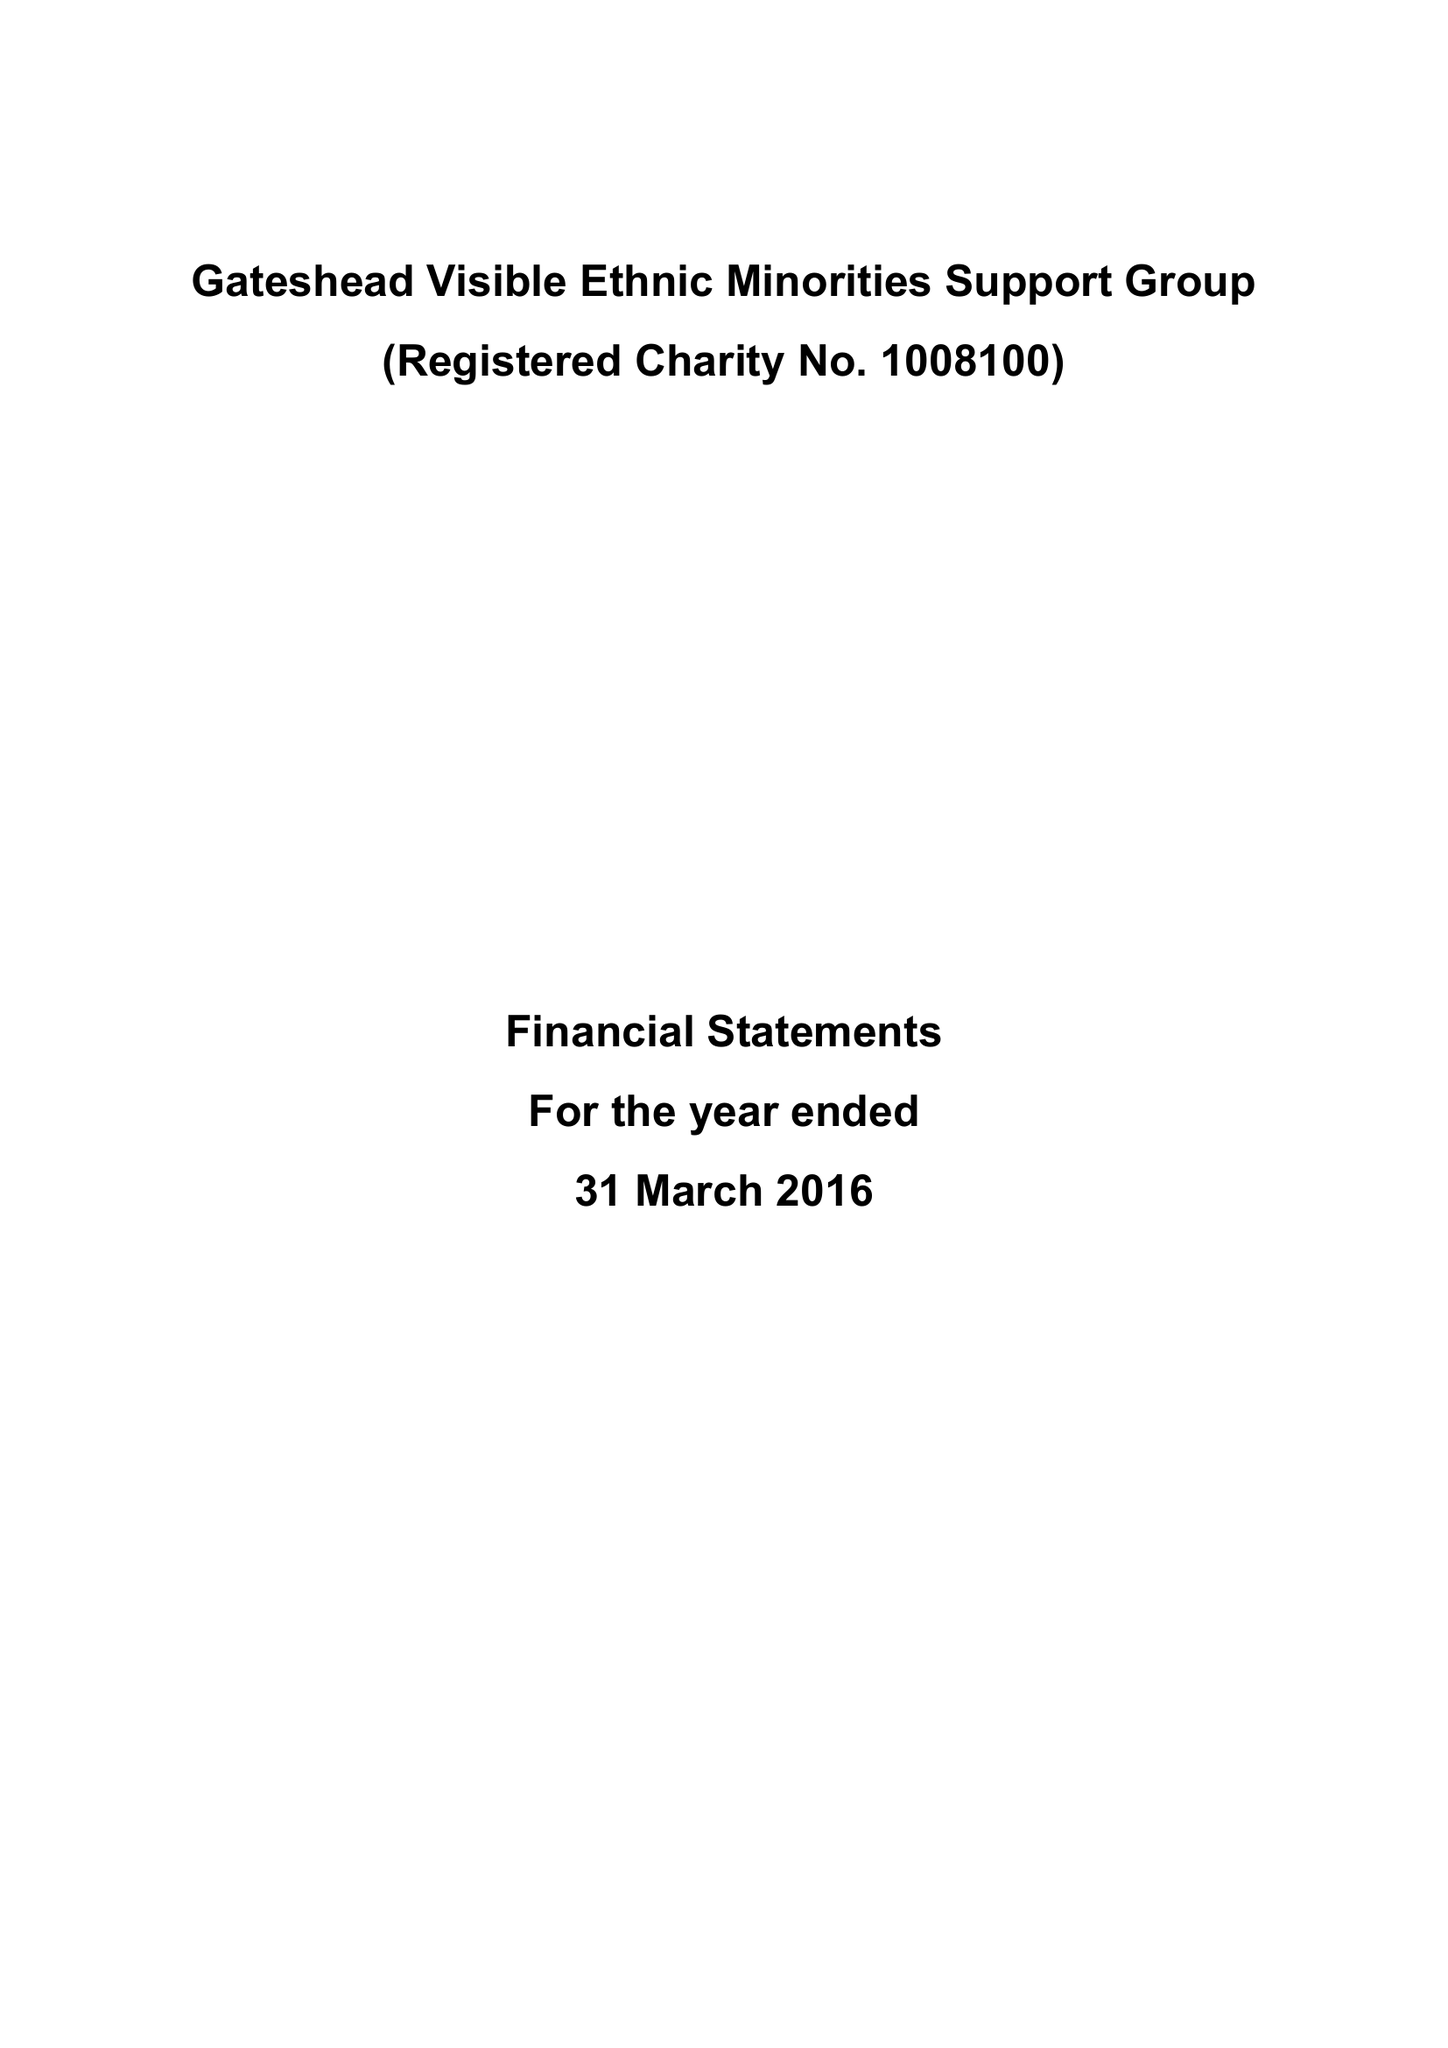What is the value for the charity_number?
Answer the question using a single word or phrase. 1008100 